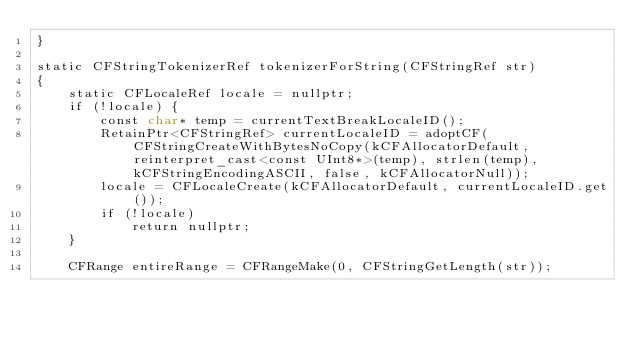<code> <loc_0><loc_0><loc_500><loc_500><_ObjectiveC_>}

static CFStringTokenizerRef tokenizerForString(CFStringRef str)
{
    static CFLocaleRef locale = nullptr;
    if (!locale) {
        const char* temp = currentTextBreakLocaleID();
        RetainPtr<CFStringRef> currentLocaleID = adoptCF(CFStringCreateWithBytesNoCopy(kCFAllocatorDefault, reinterpret_cast<const UInt8*>(temp), strlen(temp), kCFStringEncodingASCII, false, kCFAllocatorNull));
        locale = CFLocaleCreate(kCFAllocatorDefault, currentLocaleID.get());
        if (!locale)
            return nullptr;
    }

    CFRange entireRange = CFRangeMake(0, CFStringGetLength(str));    
</code> 